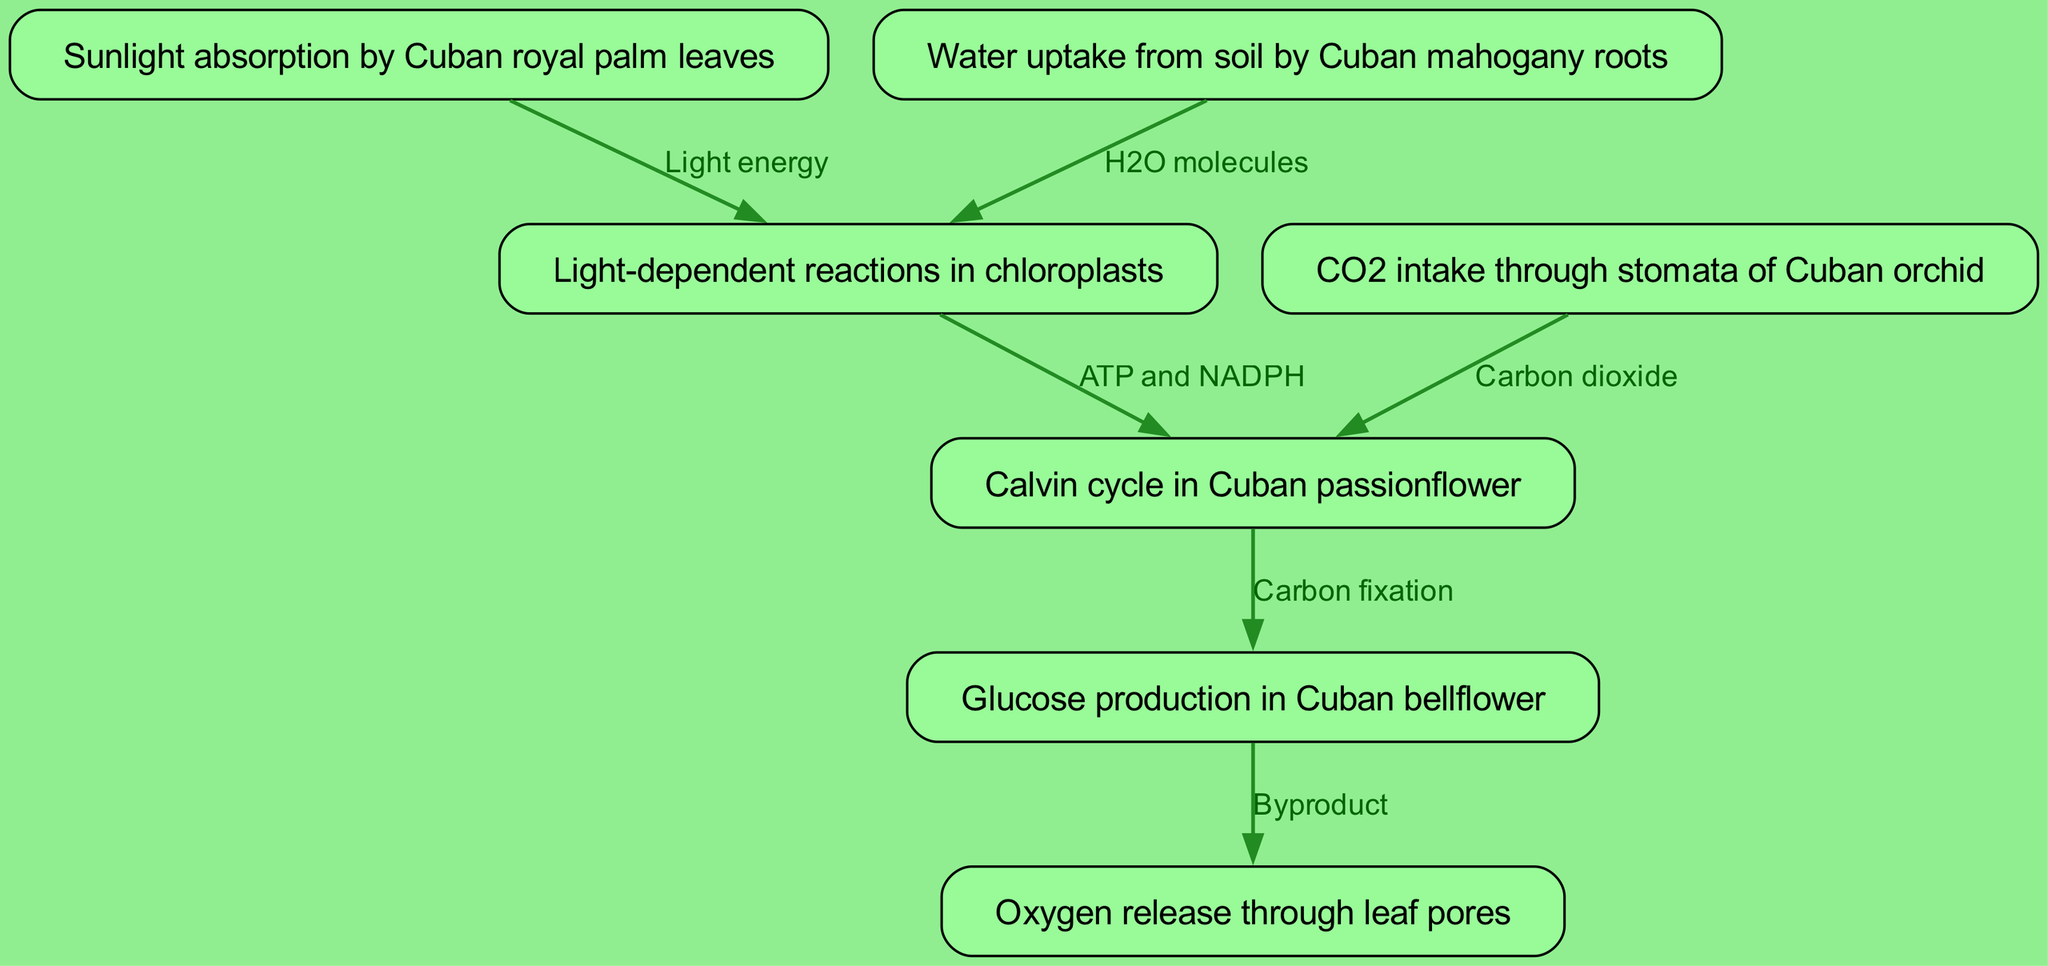What is the starting point of the photosynthesis cycle in Cuban endemic plants? The starting point of the cycle is the sunlight absorption by Cuban royal palm leaves, which is the first node in the diagram.
Answer: Sunlight absorption by Cuban royal palm leaves How many nodes are in the diagram? By counting all unique processes involved in the photosynthesis cycle represented in the diagram, there are seven nodes total.
Answer: 7 What does the Cuban orchid intake for the photosynthesis process? The Cuban orchid intakes carbon dioxide through its stomata, as indicated in the second node of the diagram.
Answer: CO2 Which Cuban plant is responsible for glucose production? The glucose production is attributed to the Cuban bellflower as shown in the sixth node of the flowchart.
Answer: Cuban bellflower What is produced as a byproduct after glucose production? The diagram indicates that oxygen is released through leaf pores after glucose production, reflecting the byproduct of the photosynthesis process.
Answer: Oxygen How many edges are there connecting the nodes in the diagram? The number of edges can be found by counting the connections or relationships between nodes in the diagram, which totals to six edges.
Answer: 6 What is the relationship between the light-dependent reactions and the Calvin cycle? The light-dependent reactions produce ATP and NADPH, which are used in the Calvin cycle as shown by the directed edge from the fourth node to the fifth node.
Answer: ATP and NADPH Which Cuban plant is involved in the water uptake process? The Cuban mahogany is responsible for the water uptake from the soil as shown in the third node of the diagram.
Answer: Cuban mahogany Which substance is released through leaf pores? The diagram specifies that oxygen is the substance released through the leaf pores, acting as a result of glucose production.
Answer: Oxygen 